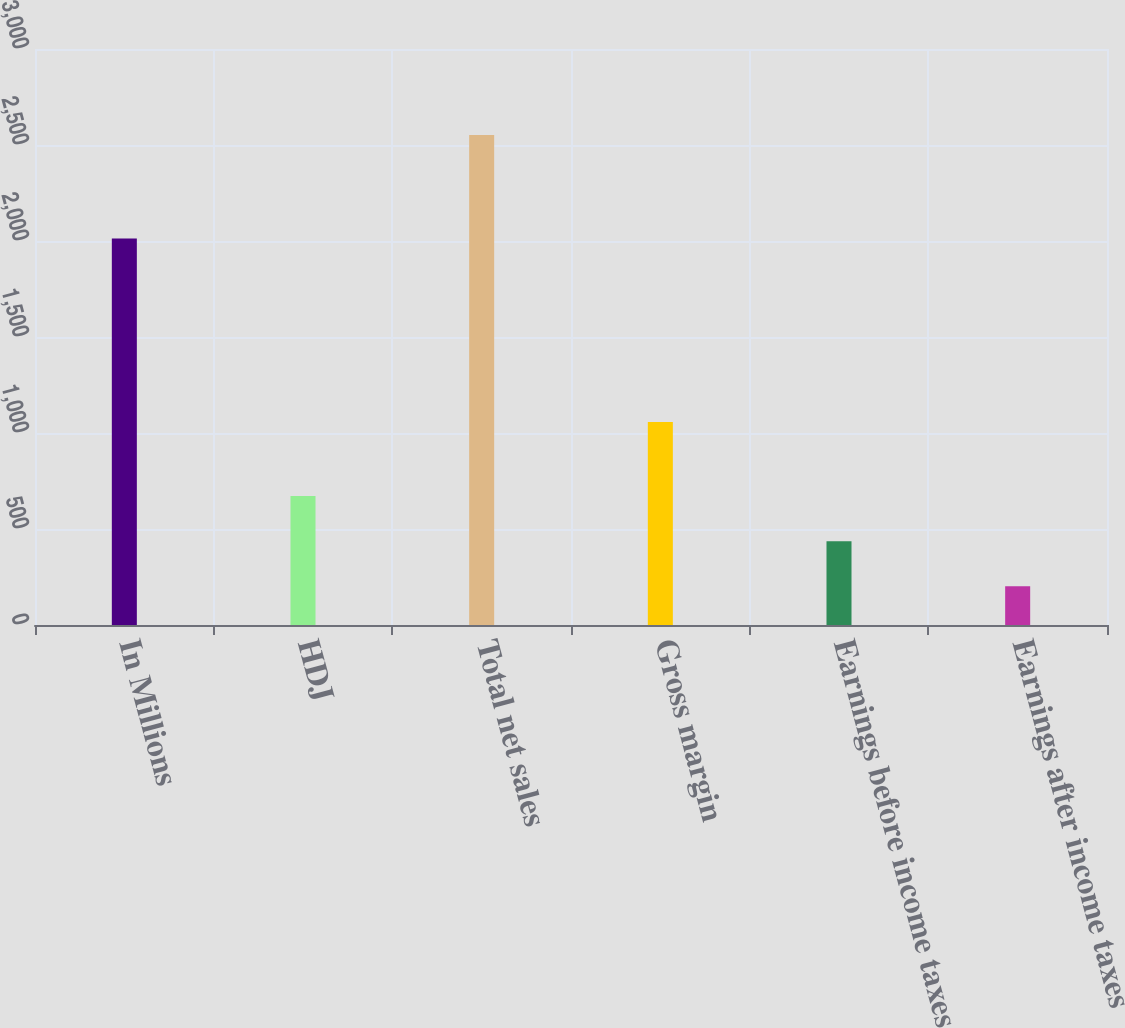Convert chart. <chart><loc_0><loc_0><loc_500><loc_500><bar_chart><fcel>In Millions<fcel>HDJ<fcel>Total net sales<fcel>Gross margin<fcel>Earnings before income taxes<fcel>Earnings after income taxes<nl><fcel>2013<fcel>671.82<fcel>2552.7<fcel>1057.3<fcel>436.71<fcel>201.6<nl></chart> 